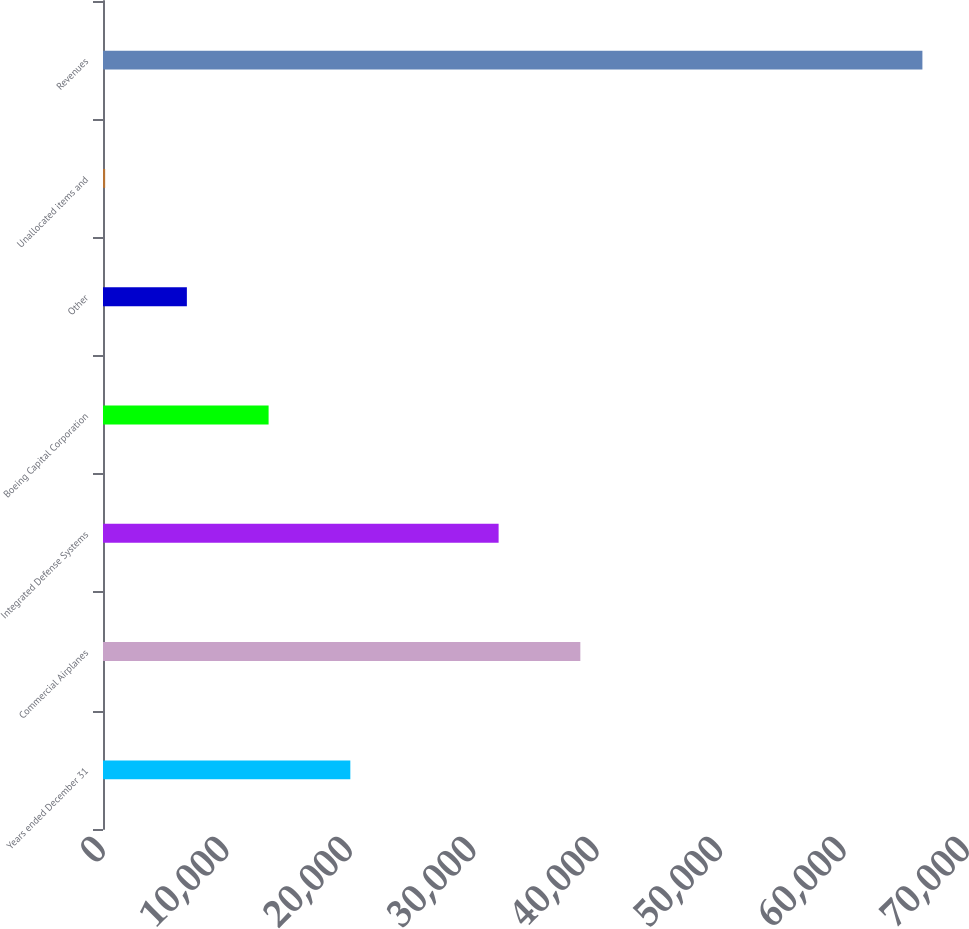Convert chart to OTSL. <chart><loc_0><loc_0><loc_500><loc_500><bar_chart><fcel>Years ended December 31<fcel>Commercial Airplanes<fcel>Integrated Defense Systems<fcel>Boeing Capital Corporation<fcel>Other<fcel>Unallocated items and<fcel>Revenues<nl><fcel>20037.9<fcel>38673.3<fcel>32052<fcel>13416.6<fcel>6795.3<fcel>174<fcel>66387<nl></chart> 